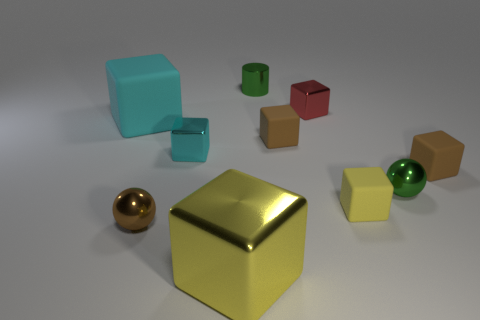Are there an equal number of small green objects on the left side of the tiny red metal block and big yellow metallic blocks to the left of the big rubber block?
Make the answer very short. No. The yellow matte object that is the same shape as the large cyan object is what size?
Provide a short and direct response. Small. There is a shiny thing that is on the right side of the green cylinder and in front of the big matte object; how big is it?
Offer a terse response. Small. Are there any small things on the left side of the red object?
Keep it short and to the point. Yes. How many things are either blocks on the right side of the large cyan rubber object or large red balls?
Offer a terse response. 6. How many small shiny cylinders are on the right side of the tiny green shiny object right of the tiny cylinder?
Ensure brevity in your answer.  0. Are there fewer tiny metal cylinders that are in front of the small cylinder than yellow shiny blocks that are behind the green sphere?
Provide a short and direct response. No. What shape is the small brown thing that is right of the sphere that is on the right side of the brown shiny ball?
Provide a short and direct response. Cube. What number of other objects are the same material as the small green sphere?
Keep it short and to the point. 5. Is there anything else that has the same size as the brown ball?
Keep it short and to the point. Yes. 